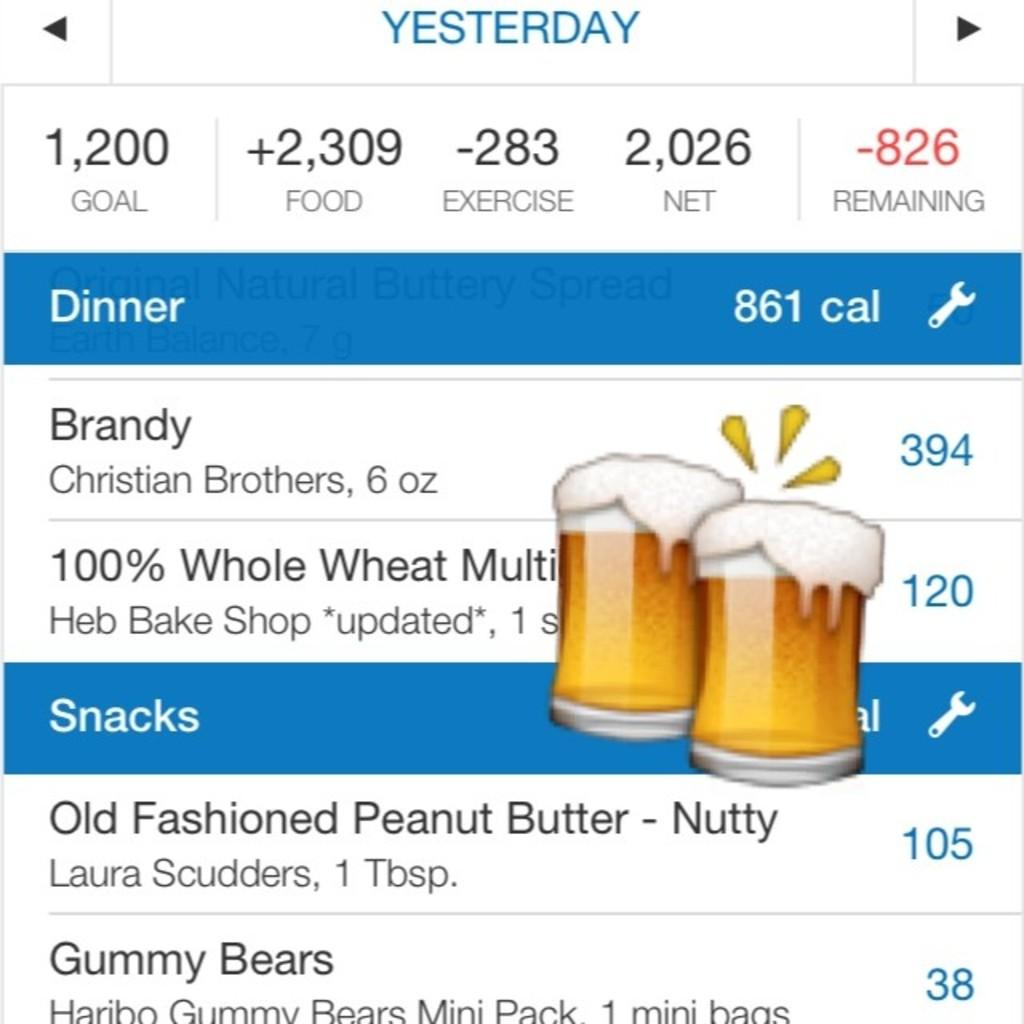<image>
Present a compact description of the photo's key features. a screen shot reading Yesterday Goal 1,200 with beer glasses on top 